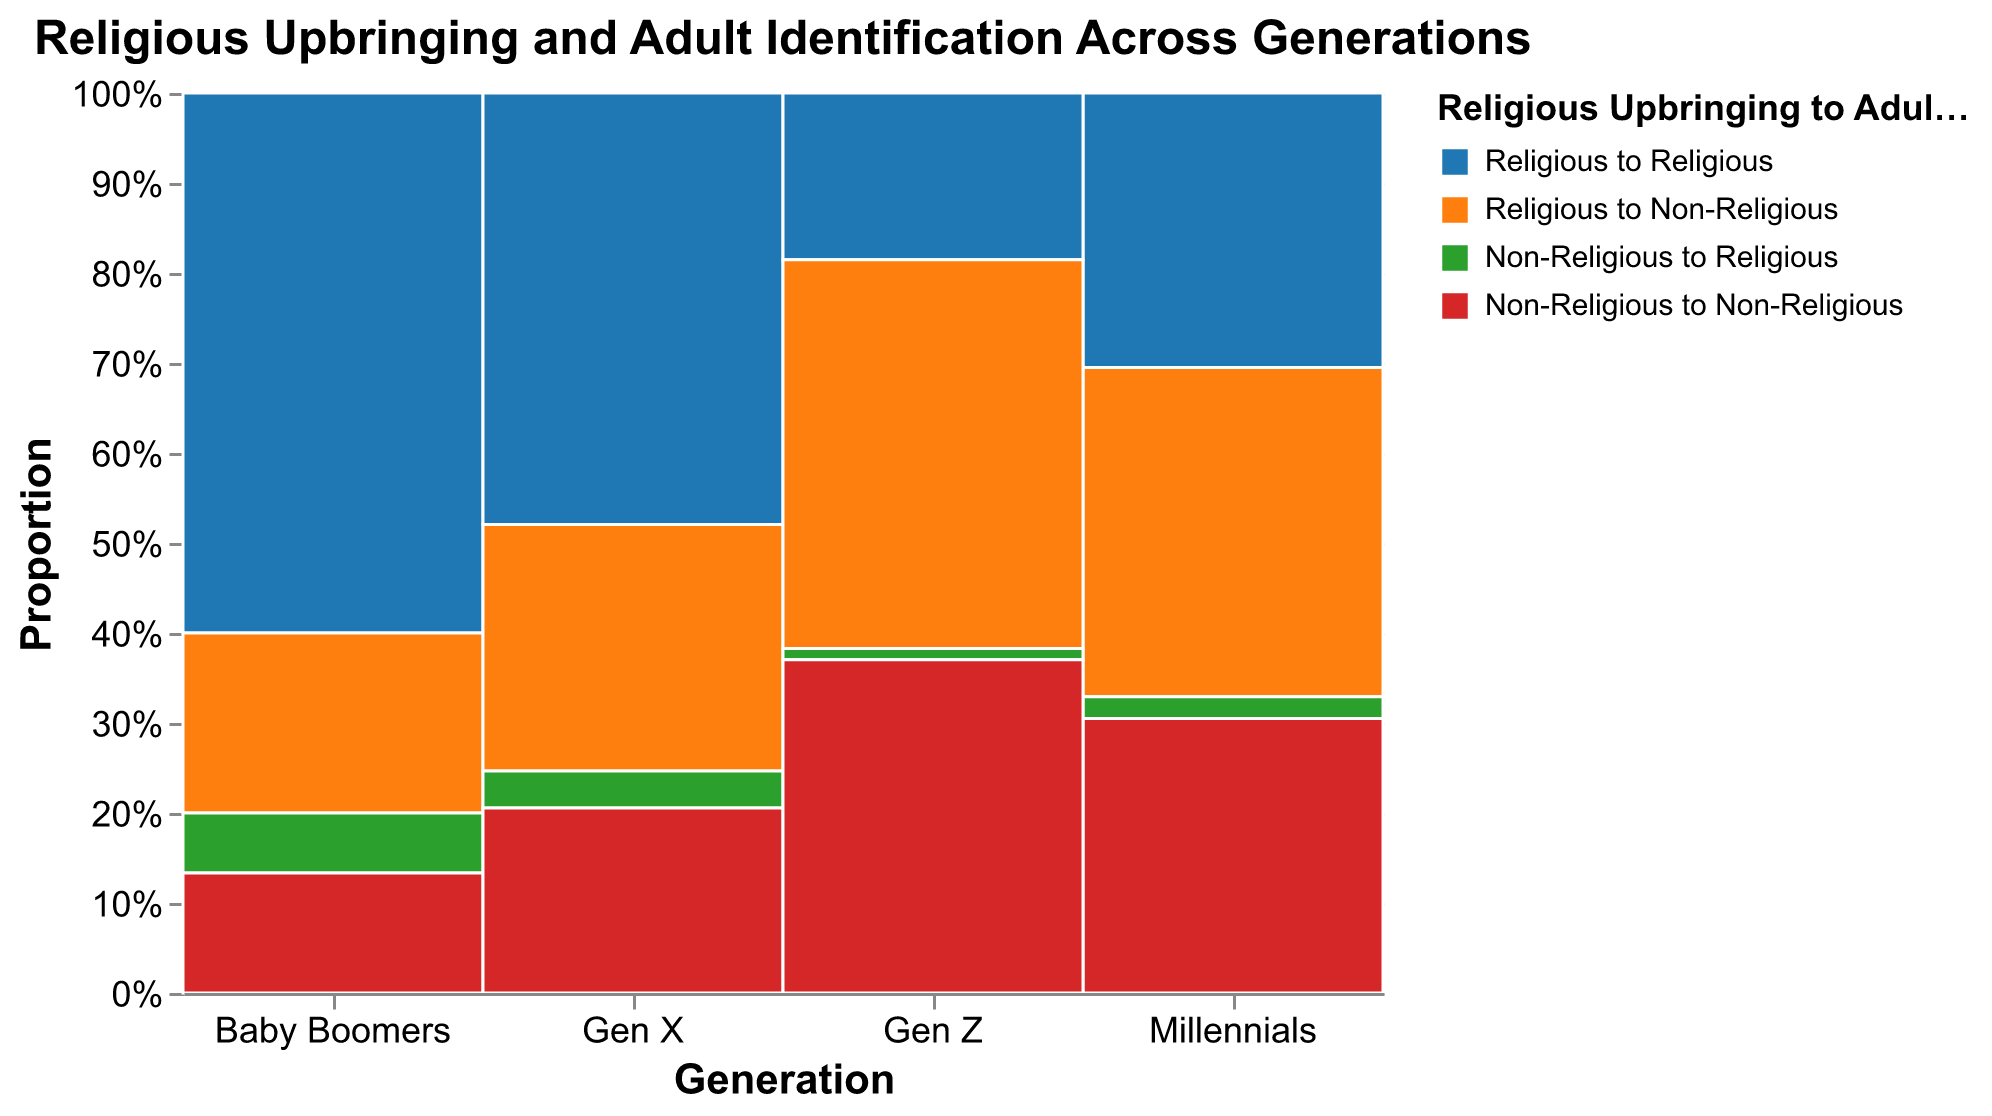What is the title of the plot? The title of the plot is found at the top of the figure and provides a quick summary of what the plot is about.
Answer: Religious Upbringing and Adult Identification Across Generations Which generation has the highest proportion of individuals who were raised religious and identify as religious adults? To find this, look for the section of the plot labeled "Religious to Religious" and identify which generation's segment is the largest.
Answer: Baby Boomers Do Millennials have a higher percentage of adults who identify as non-religious despite being raised religious compared to Gen X? Compare the heights of the segments labeled "Religious to Non-Religious" for Millennials and Gen X to see which one is taller.
Answer: Yes Among Gen Z, what is the proportion of individuals who identify as non-religious in adulthood regardless of their upbringing? Add the heights of the segments for "Religious to Non-Religious" and "Non-Religious to Non-Religious" for Gen Z and compare it to the total height.
Answer: 65% What is the total number of Baby Boomers represented in the plot? Add the counts of all segments for Baby Boomers: 450 (Religious to Religious) + 150 (Religious to Non-Religious) + 50 (Non-Religious to Religious) + 100 (Non-Religious to Non-Religious).
Answer: 750 Does Gen X have a higher proportion of individuals who identify as religious in adulthood compared to Millennials? Compare the combined heights of "Religious to Religious" and "Non-Religious to Religious" segments for Gen X and Millennials.
Answer: Yes Between which two generational groups is there the largest difference in the proportion of individuals who were raised non-religious and identify as non-religious adults? Compare the "Non-Religious to Non-Religious" segments across all generational groups to find the largest difference.
Answer: Millennials and Baby Boomers What category for Gen Z has the smallest proportion? Identify the smallest segment height in the Gen Z column.
Answer: Non-Religious to Religious What trend can be observed about religious identification in adulthood for those raised non-religious across generations? By looking at the "Non-Religious to Religious" and "Non-Religious to Non-Religious" segments across all generations, assess the trend.
Answer: Increasing non-religiosity 